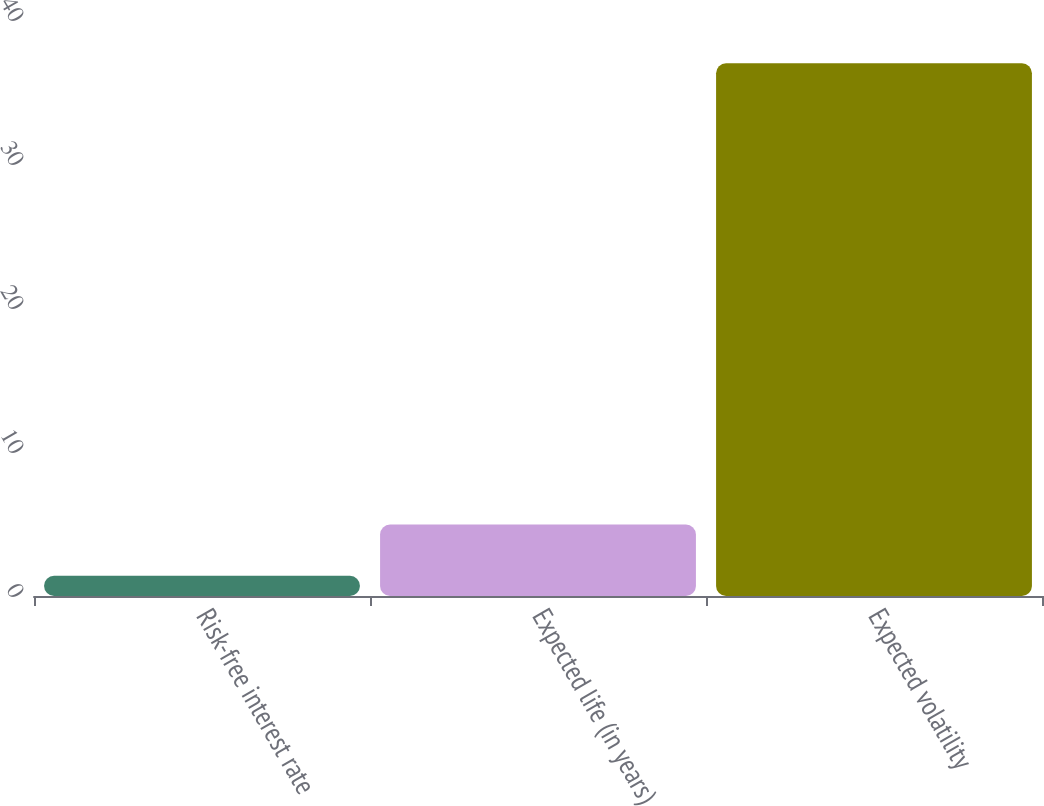<chart> <loc_0><loc_0><loc_500><loc_500><bar_chart><fcel>Risk-free interest rate<fcel>Expected life (in years)<fcel>Expected volatility<nl><fcel>1.4<fcel>4.96<fcel>37<nl></chart> 